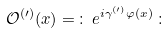<formula> <loc_0><loc_0><loc_500><loc_500>\mathcal { O } ^ { ( \prime ) } ( x ) = \, \colon \, e ^ { i \gamma ^ { ( \prime ) } \varphi ( x ) } \, \colon</formula> 